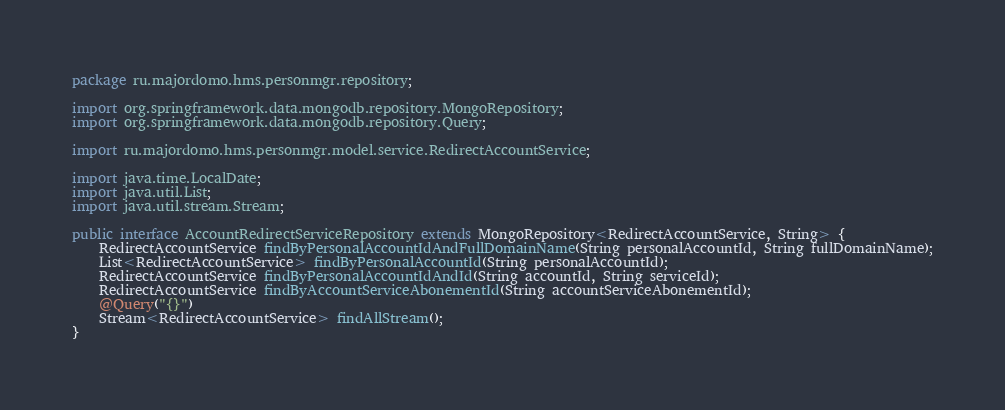<code> <loc_0><loc_0><loc_500><loc_500><_Java_>package ru.majordomo.hms.personmgr.repository;

import org.springframework.data.mongodb.repository.MongoRepository;
import org.springframework.data.mongodb.repository.Query;

import ru.majordomo.hms.personmgr.model.service.RedirectAccountService;

import java.time.LocalDate;
import java.util.List;
import java.util.stream.Stream;

public interface AccountRedirectServiceRepository extends MongoRepository<RedirectAccountService, String> {
    RedirectAccountService findByPersonalAccountIdAndFullDomainName(String personalAccountId, String fullDomainName);
    List<RedirectAccountService> findByPersonalAccountId(String personalAccountId);
    RedirectAccountService findByPersonalAccountIdAndId(String accountId, String serviceId);
    RedirectAccountService findByAccountServiceAbonementId(String accountServiceAbonementId);
    @Query("{}")
    Stream<RedirectAccountService> findAllStream();
}
</code> 